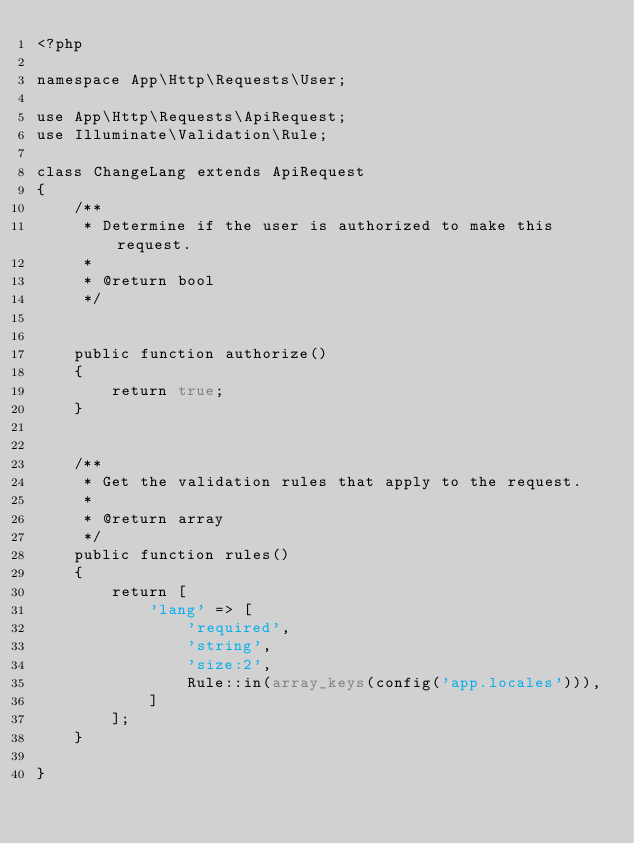<code> <loc_0><loc_0><loc_500><loc_500><_PHP_><?php

namespace App\Http\Requests\User;

use App\Http\Requests\ApiRequest;
use Illuminate\Validation\Rule;

class ChangeLang extends ApiRequest
{
    /**
     * Determine if the user is authorized to make this request.
     *
     * @return bool
     */


    public function authorize()
    {
        return true;
    }


    /**
     * Get the validation rules that apply to the request.
     *
     * @return array
     */
    public function rules()
    {
        return [
            'lang' => [
                'required',
                'string',
                'size:2',
                Rule::in(array_keys(config('app.locales'))),
            ]
        ];
    }
    
}
</code> 